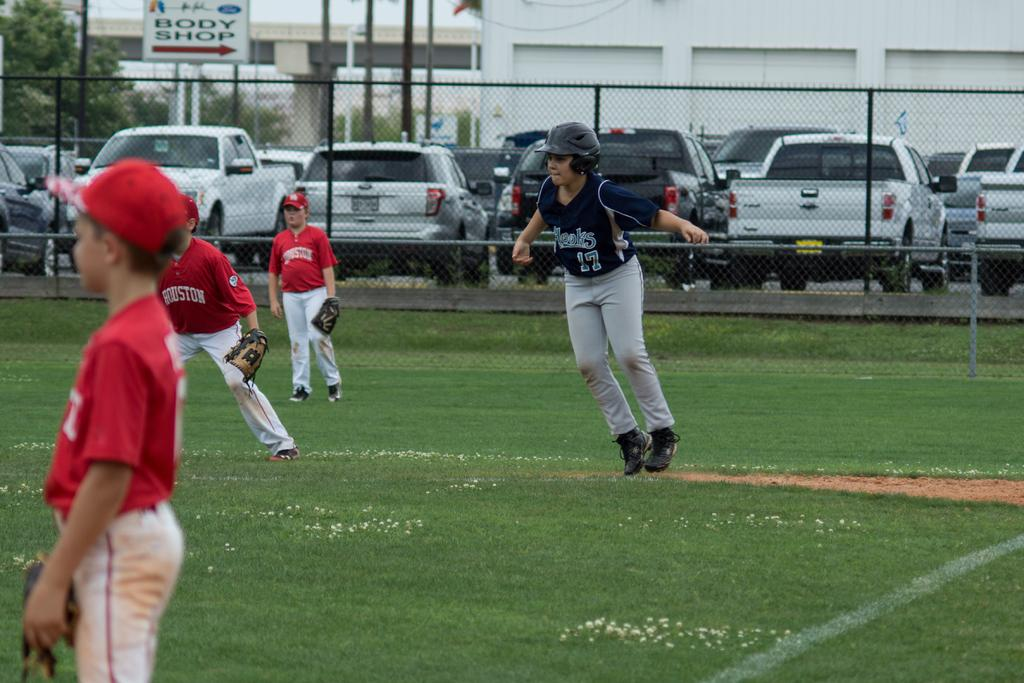Provide a one-sentence caption for the provided image. The team in red jersey is the Team Houston. 